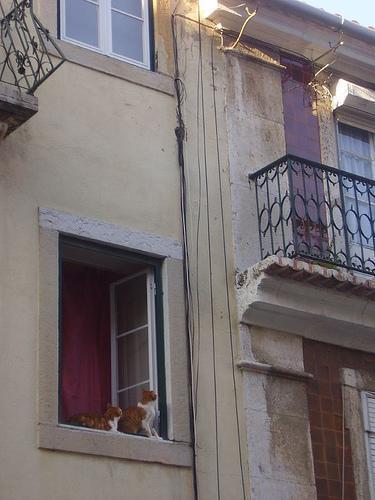How many cats are in this photo?
Give a very brief answer. 2. How many windows are open?
Give a very brief answer. 1. 